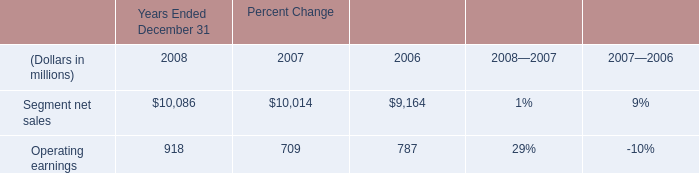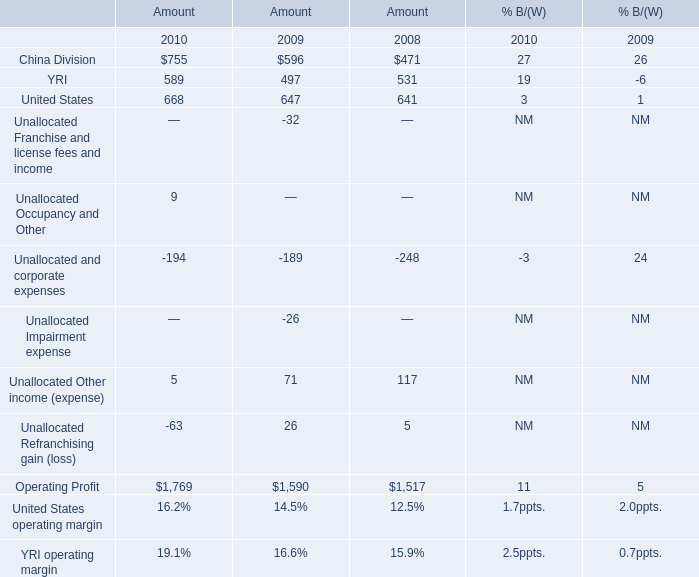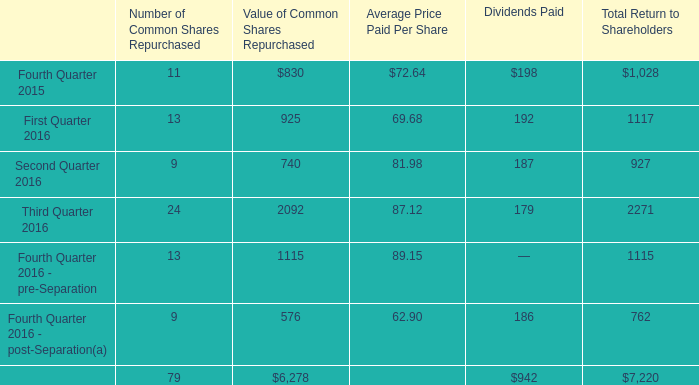How many operating profit exceed the average of operating profit in 2009? 
Computations: ((((((((596 + 497) + 647) - 32) - 189) - 26) + 71) + 26) / 8)
Answer: 198.75. 